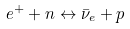<formula> <loc_0><loc_0><loc_500><loc_500>e ^ { + } + n \leftrightarrow \bar { \nu } _ { e } + p</formula> 